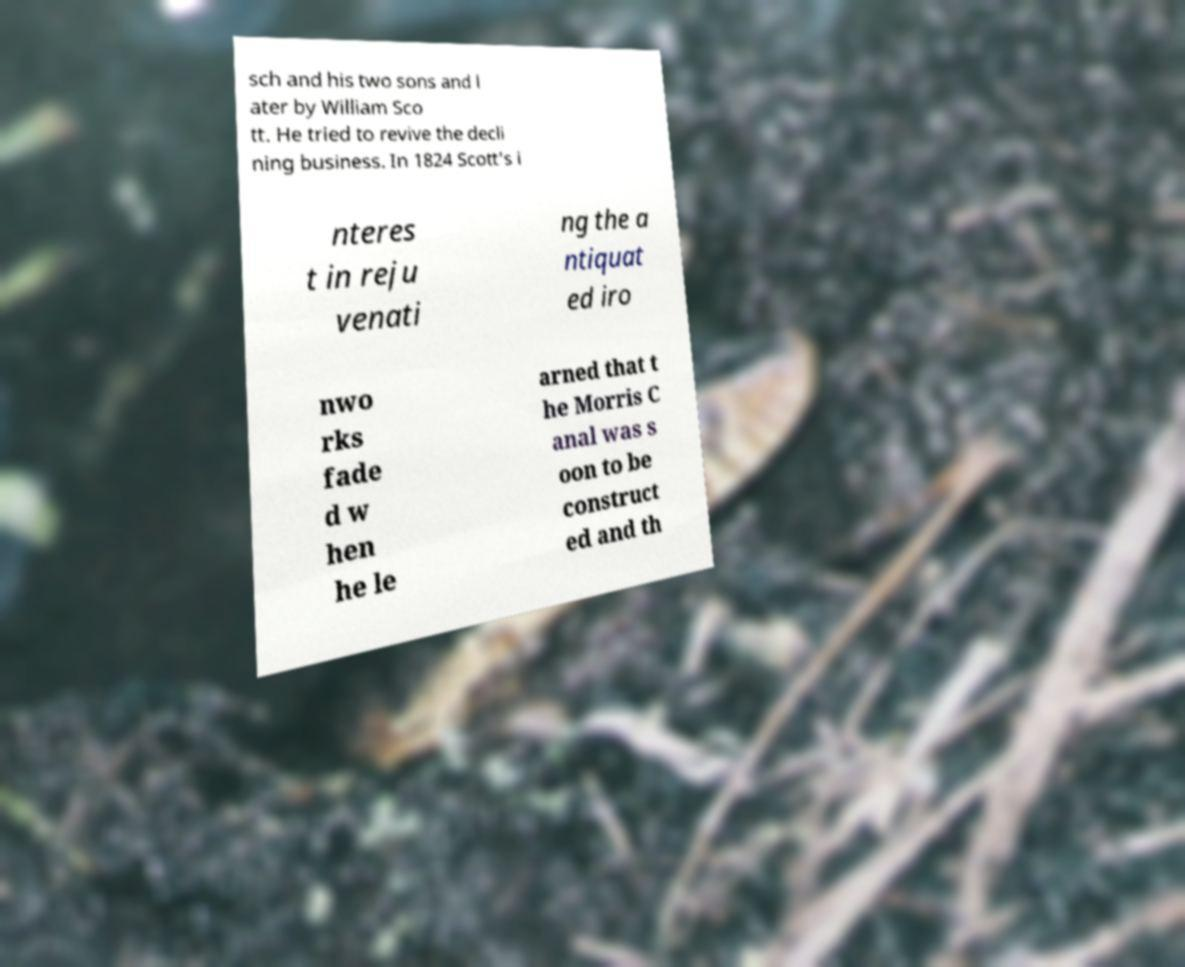Please identify and transcribe the text found in this image. sch and his two sons and l ater by William Sco tt. He tried to revive the decli ning business. In 1824 Scott's i nteres t in reju venati ng the a ntiquat ed iro nwo rks fade d w hen he le arned that t he Morris C anal was s oon to be construct ed and th 